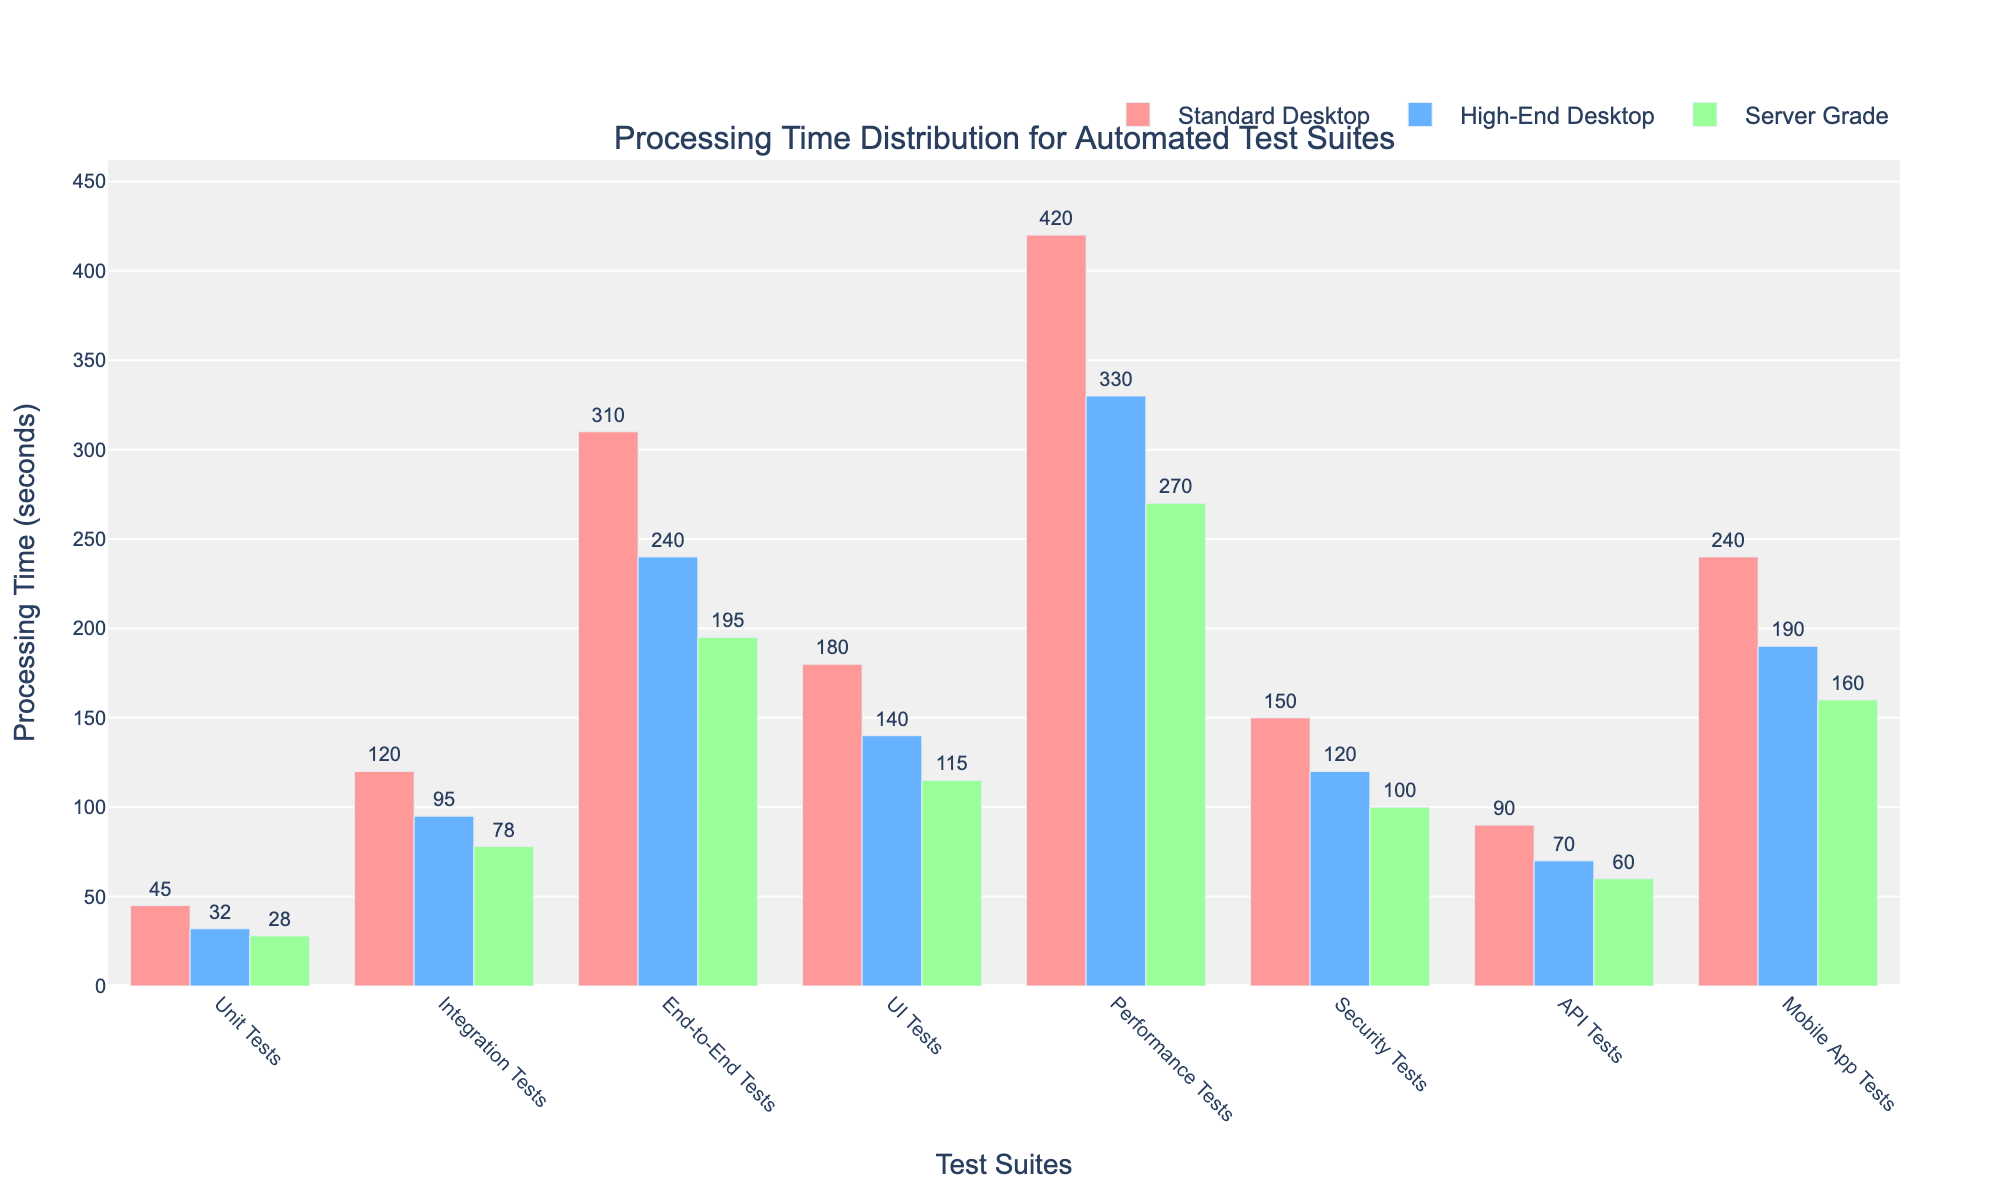Which test suite has the shortest processing time on the Server Grade hardware? By observing the height of the bars corresponding to each test suite for Server Grade hardware, the shortest bar represents the test suite with the shortest processing time. Specifically, this test suite is "Unit Tests" with a time of 28 seconds.
Answer: Unit Tests How does the processing time of UI Tests on a Standard Desktop compare to a High-End Desktop? By comparing the heights of the bars for UI Tests across the two hardware types, we confirm that the processing time is shorter on the High-End Desktop (140 seconds) than on the Standard Desktop (180 seconds).
Answer: Higher on Standard Desktop Which hardware configuration consistently shows the fastest processing times across all test suites? By observing the heights of the bars grouped by hardware configuration across all the test suites, Server Grade hardware always has the shortest bars, indicating the quickest processing times for all test suites.
Answer: Server Grade What's the total processing time for End-to-End Tests across all hardware configurations? To determine this, we sum the processing times for End-to-End Tests on Standard Desktop (310 seconds), High-End Desktop (240 seconds), and Server Grade (195 seconds). 310 + 240 + 195 = 745 seconds.
Answer: 745 seconds For Performance Tests, what is the difference in processing time between the Standard Desktop and Server Grade? The processing time for Performance Tests on Standard Desktop is 420 seconds and for Server Grade is 270 seconds. The difference is calculated as 420 - 270 = 150 seconds.
Answer: 150 seconds How many test suites have a processing time over 100 seconds on a Standard Desktop? By counting the bars representing a processing time greater than 100 seconds for Standard Desktop hardware, we find that there are five test suites: Integration Tests, End-to-End Tests, UI Tests, Performance Tests, and Security Tests.
Answer: 5 test suites Which test suite shows the largest reduction in processing time from Standard Desktop to Server Grade? By comparing the processing times for each test suite on Standard Desktop and Server Grade hardware, the largest reduction is seen with Performance Tests: 420 seconds (Standard Desktop) - 270 seconds (Server Grade) = 150 seconds.
Answer: Performance Tests What is the average processing time for Integration Tests across all hardware configurations? Calculate the average by summing the processing times for Integration Tests on Standard Desktop (120 seconds), High-End Desktop (95 seconds), and Server Grade (78 seconds), and then dividing by 3: (120 + 95 + 78) / 3 = 97.67 seconds.
Answer: 97.67 seconds Which hardware configuration for Mobile App Tests has a processing time closest to the overall average processing time for this test suite? First, calculate the average processing time for Mobile App Tests across all hardware: (240 + 190 + 160) / 3 = 196.67 seconds. The processing time closest to this average is for High-End Desktop at 190 seconds.
Answer: High-End Desktop Is there any test suite where the processing time difference between Standard Desktop and High-End Desktop is greater than 100 seconds? By comparing the processing time differences across test suites, End-to-End Tests display a difference of 310 seconds (Standard Desktop) - 240 seconds (High-End Desktop) = 70 seconds, which is less than 100. Thus, no test suite has a processing time difference exceeding 100 seconds.
Answer: No 